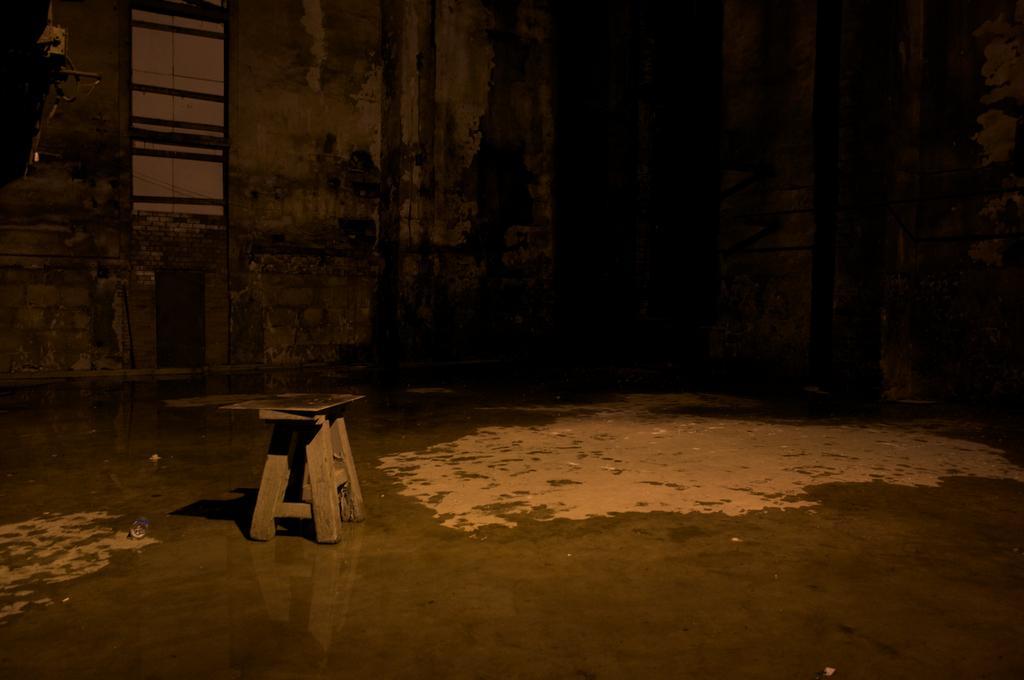In one or two sentences, can you explain what this image depicts? In this image in the center there is one stool and in the background there is a wall, window and at the bottom there is a floor. 